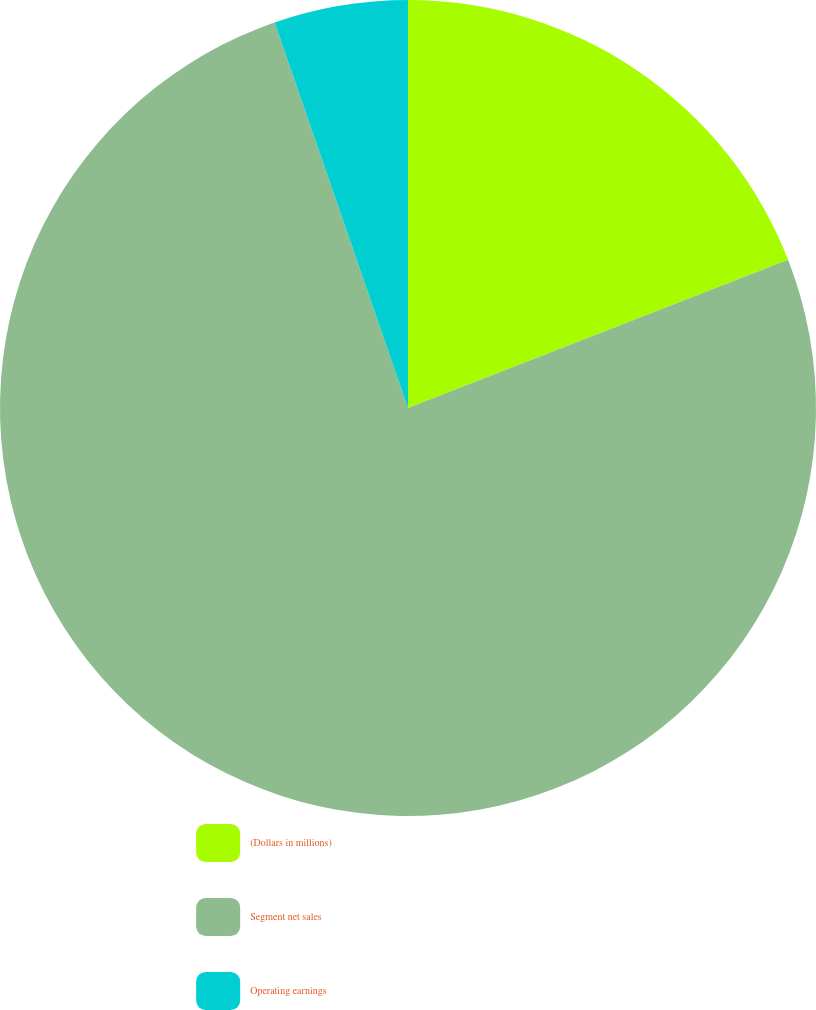Convert chart. <chart><loc_0><loc_0><loc_500><loc_500><pie_chart><fcel>(Dollars in millions)<fcel>Segment net sales<fcel>Operating earnings<nl><fcel>19.08%<fcel>75.62%<fcel>5.3%<nl></chart> 